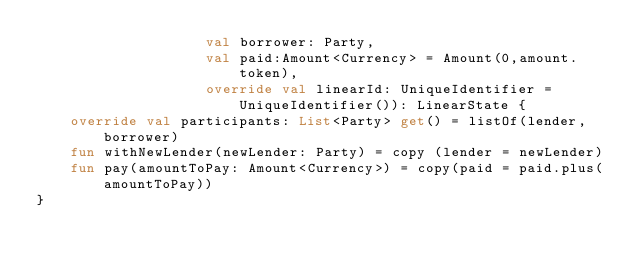Convert code to text. <code><loc_0><loc_0><loc_500><loc_500><_Kotlin_>                    val borrower: Party,
                    val paid:Amount<Currency> = Amount(0,amount.token),
                    override val linearId: UniqueIdentifier = UniqueIdentifier()): LinearState {
    override val participants: List<Party> get() = listOf(lender,borrower)
    fun withNewLender(newLender: Party) = copy (lender = newLender)
    fun pay(amountToPay: Amount<Currency>) = copy(paid = paid.plus(amountToPay))
}
</code> 